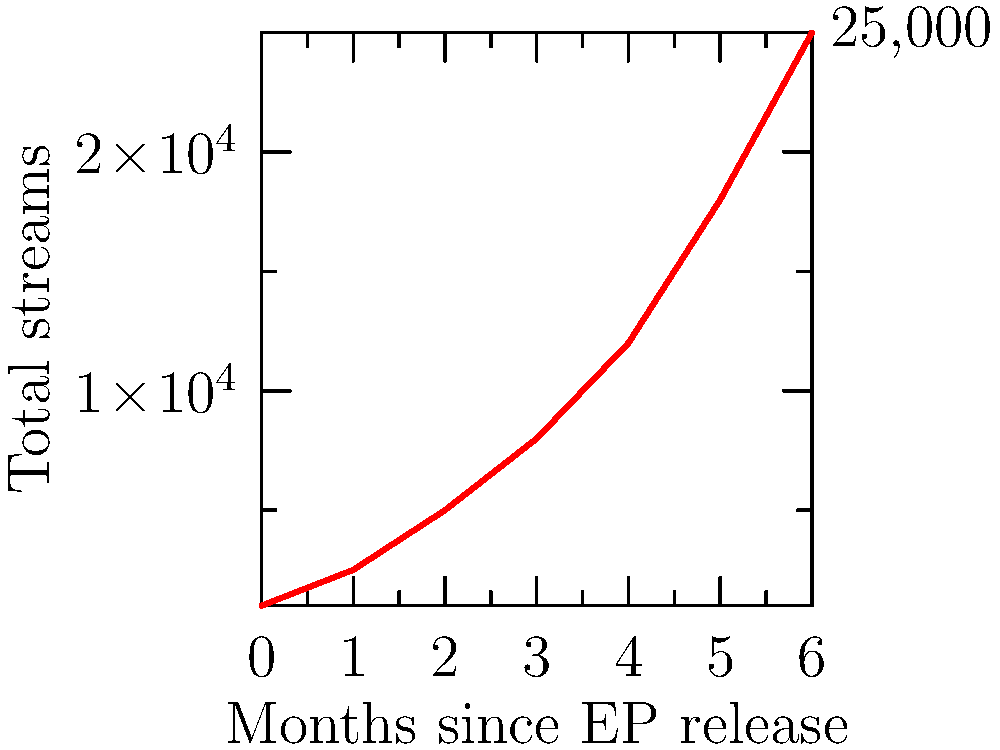Based on the line graph showing the growth of streaming numbers over time for your debut EP, what was the approximate percentage increase in total streams from month 3 to month 6 after the release? To calculate the percentage increase in total streams from month 3 to month 6:

1. Identify the number of streams at month 3: 8,000
2. Identify the number of streams at month 6: 25,000
3. Calculate the difference: 25,000 - 8,000 = 17,000
4. Calculate the percentage increase:
   $\frac{\text{Increase}}{\text{Original Value}} \times 100\% = \frac{17,000}{8,000} \times 100\% = 212.5\%$

The total streams increased by approximately 212.5% from month 3 to month 6 after the EP release.
Answer: 212.5% 